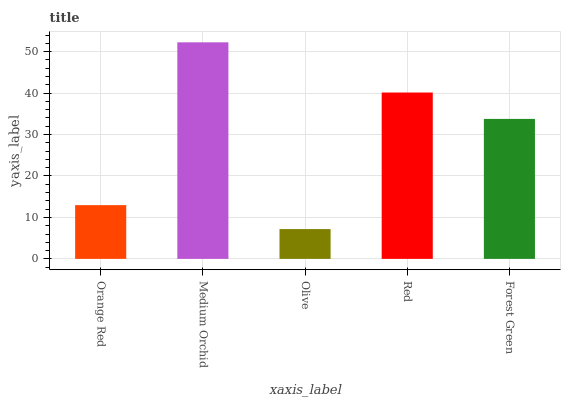Is Olive the minimum?
Answer yes or no. Yes. Is Medium Orchid the maximum?
Answer yes or no. Yes. Is Medium Orchid the minimum?
Answer yes or no. No. Is Olive the maximum?
Answer yes or no. No. Is Medium Orchid greater than Olive?
Answer yes or no. Yes. Is Olive less than Medium Orchid?
Answer yes or no. Yes. Is Olive greater than Medium Orchid?
Answer yes or no. No. Is Medium Orchid less than Olive?
Answer yes or no. No. Is Forest Green the high median?
Answer yes or no. Yes. Is Forest Green the low median?
Answer yes or no. Yes. Is Medium Orchid the high median?
Answer yes or no. No. Is Olive the low median?
Answer yes or no. No. 